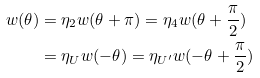Convert formula to latex. <formula><loc_0><loc_0><loc_500><loc_500>w ( \theta ) & = \eta _ { 2 } w ( \theta + \pi ) = \eta _ { 4 } w ( \theta + \frac { \pi } { 2 } ) \\ & = \eta _ { U } w ( - \theta ) = \eta _ { U ^ { \prime } } w ( - \theta + \frac { \pi } { 2 } )</formula> 